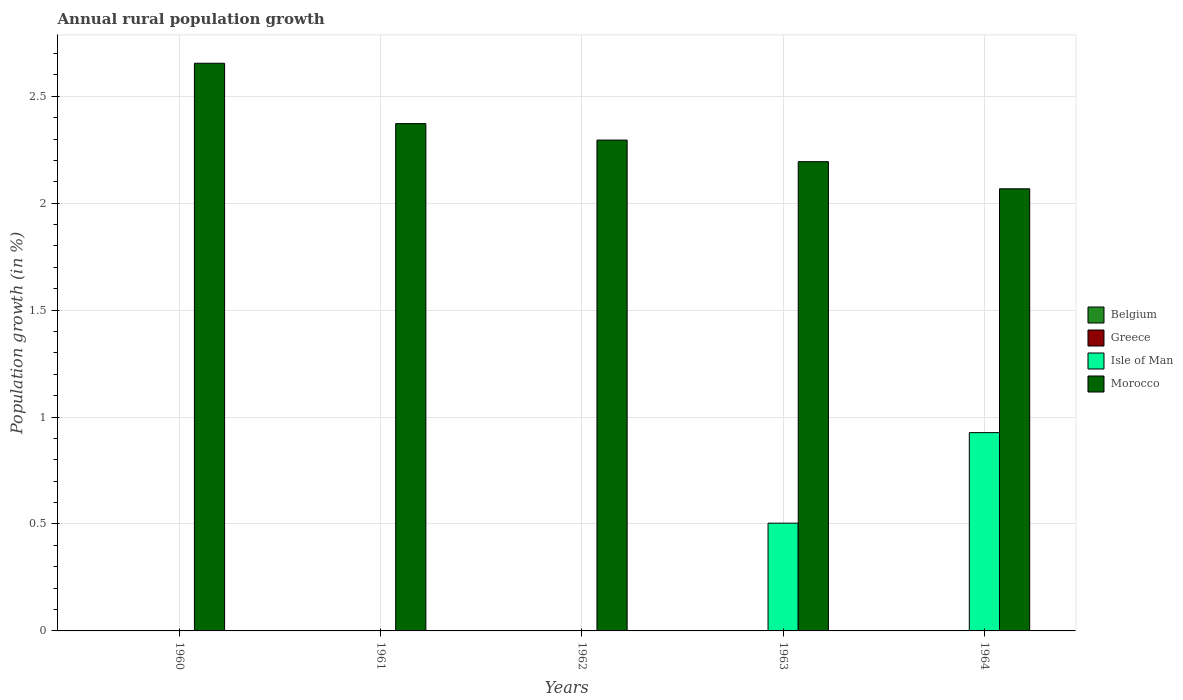How many different coloured bars are there?
Provide a short and direct response. 2. Are the number of bars per tick equal to the number of legend labels?
Provide a short and direct response. No. How many bars are there on the 3rd tick from the left?
Your answer should be compact. 1. What is the label of the 4th group of bars from the left?
Make the answer very short. 1963. What is the percentage of rural population growth in Morocco in 1964?
Your response must be concise. 2.07. Across all years, what is the maximum percentage of rural population growth in Isle of Man?
Give a very brief answer. 0.93. Across all years, what is the minimum percentage of rural population growth in Morocco?
Ensure brevity in your answer.  2.07. In which year was the percentage of rural population growth in Isle of Man maximum?
Your response must be concise. 1964. What is the total percentage of rural population growth in Morocco in the graph?
Your answer should be very brief. 11.58. What is the difference between the percentage of rural population growth in Morocco in 1960 and that in 1964?
Your answer should be very brief. 0.59. What is the difference between the percentage of rural population growth in Morocco in 1962 and the percentage of rural population growth in Belgium in 1964?
Your answer should be compact. 2.3. What is the average percentage of rural population growth in Isle of Man per year?
Provide a succinct answer. 0.29. In the year 1963, what is the difference between the percentage of rural population growth in Isle of Man and percentage of rural population growth in Morocco?
Ensure brevity in your answer.  -1.69. What is the ratio of the percentage of rural population growth in Morocco in 1960 to that in 1962?
Your answer should be compact. 1.16. What is the difference between the highest and the lowest percentage of rural population growth in Isle of Man?
Give a very brief answer. 0.93. In how many years, is the percentage of rural population growth in Isle of Man greater than the average percentage of rural population growth in Isle of Man taken over all years?
Keep it short and to the point. 2. Is the sum of the percentage of rural population growth in Morocco in 1961 and 1963 greater than the maximum percentage of rural population growth in Isle of Man across all years?
Provide a succinct answer. Yes. How many bars are there?
Make the answer very short. 7. What is the difference between two consecutive major ticks on the Y-axis?
Ensure brevity in your answer.  0.5. What is the title of the graph?
Your answer should be very brief. Annual rural population growth. Does "Bahrain" appear as one of the legend labels in the graph?
Offer a terse response. No. What is the label or title of the Y-axis?
Provide a short and direct response. Population growth (in %). What is the Population growth (in %) of Belgium in 1960?
Give a very brief answer. 0. What is the Population growth (in %) of Isle of Man in 1960?
Provide a short and direct response. 0. What is the Population growth (in %) of Morocco in 1960?
Provide a succinct answer. 2.65. What is the Population growth (in %) in Belgium in 1961?
Your response must be concise. 0. What is the Population growth (in %) of Greece in 1961?
Your answer should be compact. 0. What is the Population growth (in %) in Isle of Man in 1961?
Keep it short and to the point. 0. What is the Population growth (in %) of Morocco in 1961?
Make the answer very short. 2.37. What is the Population growth (in %) of Belgium in 1962?
Keep it short and to the point. 0. What is the Population growth (in %) in Isle of Man in 1962?
Ensure brevity in your answer.  0. What is the Population growth (in %) in Morocco in 1962?
Keep it short and to the point. 2.3. What is the Population growth (in %) of Belgium in 1963?
Ensure brevity in your answer.  0. What is the Population growth (in %) in Greece in 1963?
Ensure brevity in your answer.  0. What is the Population growth (in %) in Isle of Man in 1963?
Offer a very short reply. 0.5. What is the Population growth (in %) of Morocco in 1963?
Give a very brief answer. 2.19. What is the Population growth (in %) of Greece in 1964?
Your response must be concise. 0. What is the Population growth (in %) in Isle of Man in 1964?
Ensure brevity in your answer.  0.93. What is the Population growth (in %) in Morocco in 1964?
Your answer should be compact. 2.07. Across all years, what is the maximum Population growth (in %) of Isle of Man?
Ensure brevity in your answer.  0.93. Across all years, what is the maximum Population growth (in %) of Morocco?
Make the answer very short. 2.65. Across all years, what is the minimum Population growth (in %) of Morocco?
Provide a succinct answer. 2.07. What is the total Population growth (in %) of Belgium in the graph?
Give a very brief answer. 0. What is the total Population growth (in %) in Isle of Man in the graph?
Make the answer very short. 1.43. What is the total Population growth (in %) in Morocco in the graph?
Provide a succinct answer. 11.58. What is the difference between the Population growth (in %) of Morocco in 1960 and that in 1961?
Provide a succinct answer. 0.28. What is the difference between the Population growth (in %) in Morocco in 1960 and that in 1962?
Give a very brief answer. 0.36. What is the difference between the Population growth (in %) in Morocco in 1960 and that in 1963?
Give a very brief answer. 0.46. What is the difference between the Population growth (in %) in Morocco in 1960 and that in 1964?
Your answer should be very brief. 0.59. What is the difference between the Population growth (in %) of Morocco in 1961 and that in 1962?
Provide a succinct answer. 0.08. What is the difference between the Population growth (in %) of Morocco in 1961 and that in 1963?
Your answer should be compact. 0.18. What is the difference between the Population growth (in %) of Morocco in 1961 and that in 1964?
Your answer should be very brief. 0.3. What is the difference between the Population growth (in %) of Morocco in 1962 and that in 1963?
Your answer should be compact. 0.1. What is the difference between the Population growth (in %) of Morocco in 1962 and that in 1964?
Offer a terse response. 0.23. What is the difference between the Population growth (in %) of Isle of Man in 1963 and that in 1964?
Provide a short and direct response. -0.42. What is the difference between the Population growth (in %) in Morocco in 1963 and that in 1964?
Keep it short and to the point. 0.13. What is the difference between the Population growth (in %) of Isle of Man in 1963 and the Population growth (in %) of Morocco in 1964?
Offer a very short reply. -1.56. What is the average Population growth (in %) in Belgium per year?
Make the answer very short. 0. What is the average Population growth (in %) in Isle of Man per year?
Your answer should be compact. 0.29. What is the average Population growth (in %) of Morocco per year?
Your answer should be compact. 2.32. In the year 1963, what is the difference between the Population growth (in %) of Isle of Man and Population growth (in %) of Morocco?
Make the answer very short. -1.69. In the year 1964, what is the difference between the Population growth (in %) in Isle of Man and Population growth (in %) in Morocco?
Give a very brief answer. -1.14. What is the ratio of the Population growth (in %) in Morocco in 1960 to that in 1961?
Your response must be concise. 1.12. What is the ratio of the Population growth (in %) in Morocco in 1960 to that in 1962?
Provide a short and direct response. 1.16. What is the ratio of the Population growth (in %) in Morocco in 1960 to that in 1963?
Offer a very short reply. 1.21. What is the ratio of the Population growth (in %) in Morocco in 1960 to that in 1964?
Make the answer very short. 1.28. What is the ratio of the Population growth (in %) of Morocco in 1961 to that in 1962?
Ensure brevity in your answer.  1.03. What is the ratio of the Population growth (in %) of Morocco in 1961 to that in 1963?
Offer a very short reply. 1.08. What is the ratio of the Population growth (in %) of Morocco in 1961 to that in 1964?
Your response must be concise. 1.15. What is the ratio of the Population growth (in %) of Morocco in 1962 to that in 1963?
Your answer should be compact. 1.05. What is the ratio of the Population growth (in %) in Morocco in 1962 to that in 1964?
Your answer should be very brief. 1.11. What is the ratio of the Population growth (in %) in Isle of Man in 1963 to that in 1964?
Your response must be concise. 0.54. What is the ratio of the Population growth (in %) in Morocco in 1963 to that in 1964?
Offer a very short reply. 1.06. What is the difference between the highest and the second highest Population growth (in %) in Morocco?
Ensure brevity in your answer.  0.28. What is the difference between the highest and the lowest Population growth (in %) in Isle of Man?
Offer a very short reply. 0.93. What is the difference between the highest and the lowest Population growth (in %) of Morocco?
Make the answer very short. 0.59. 